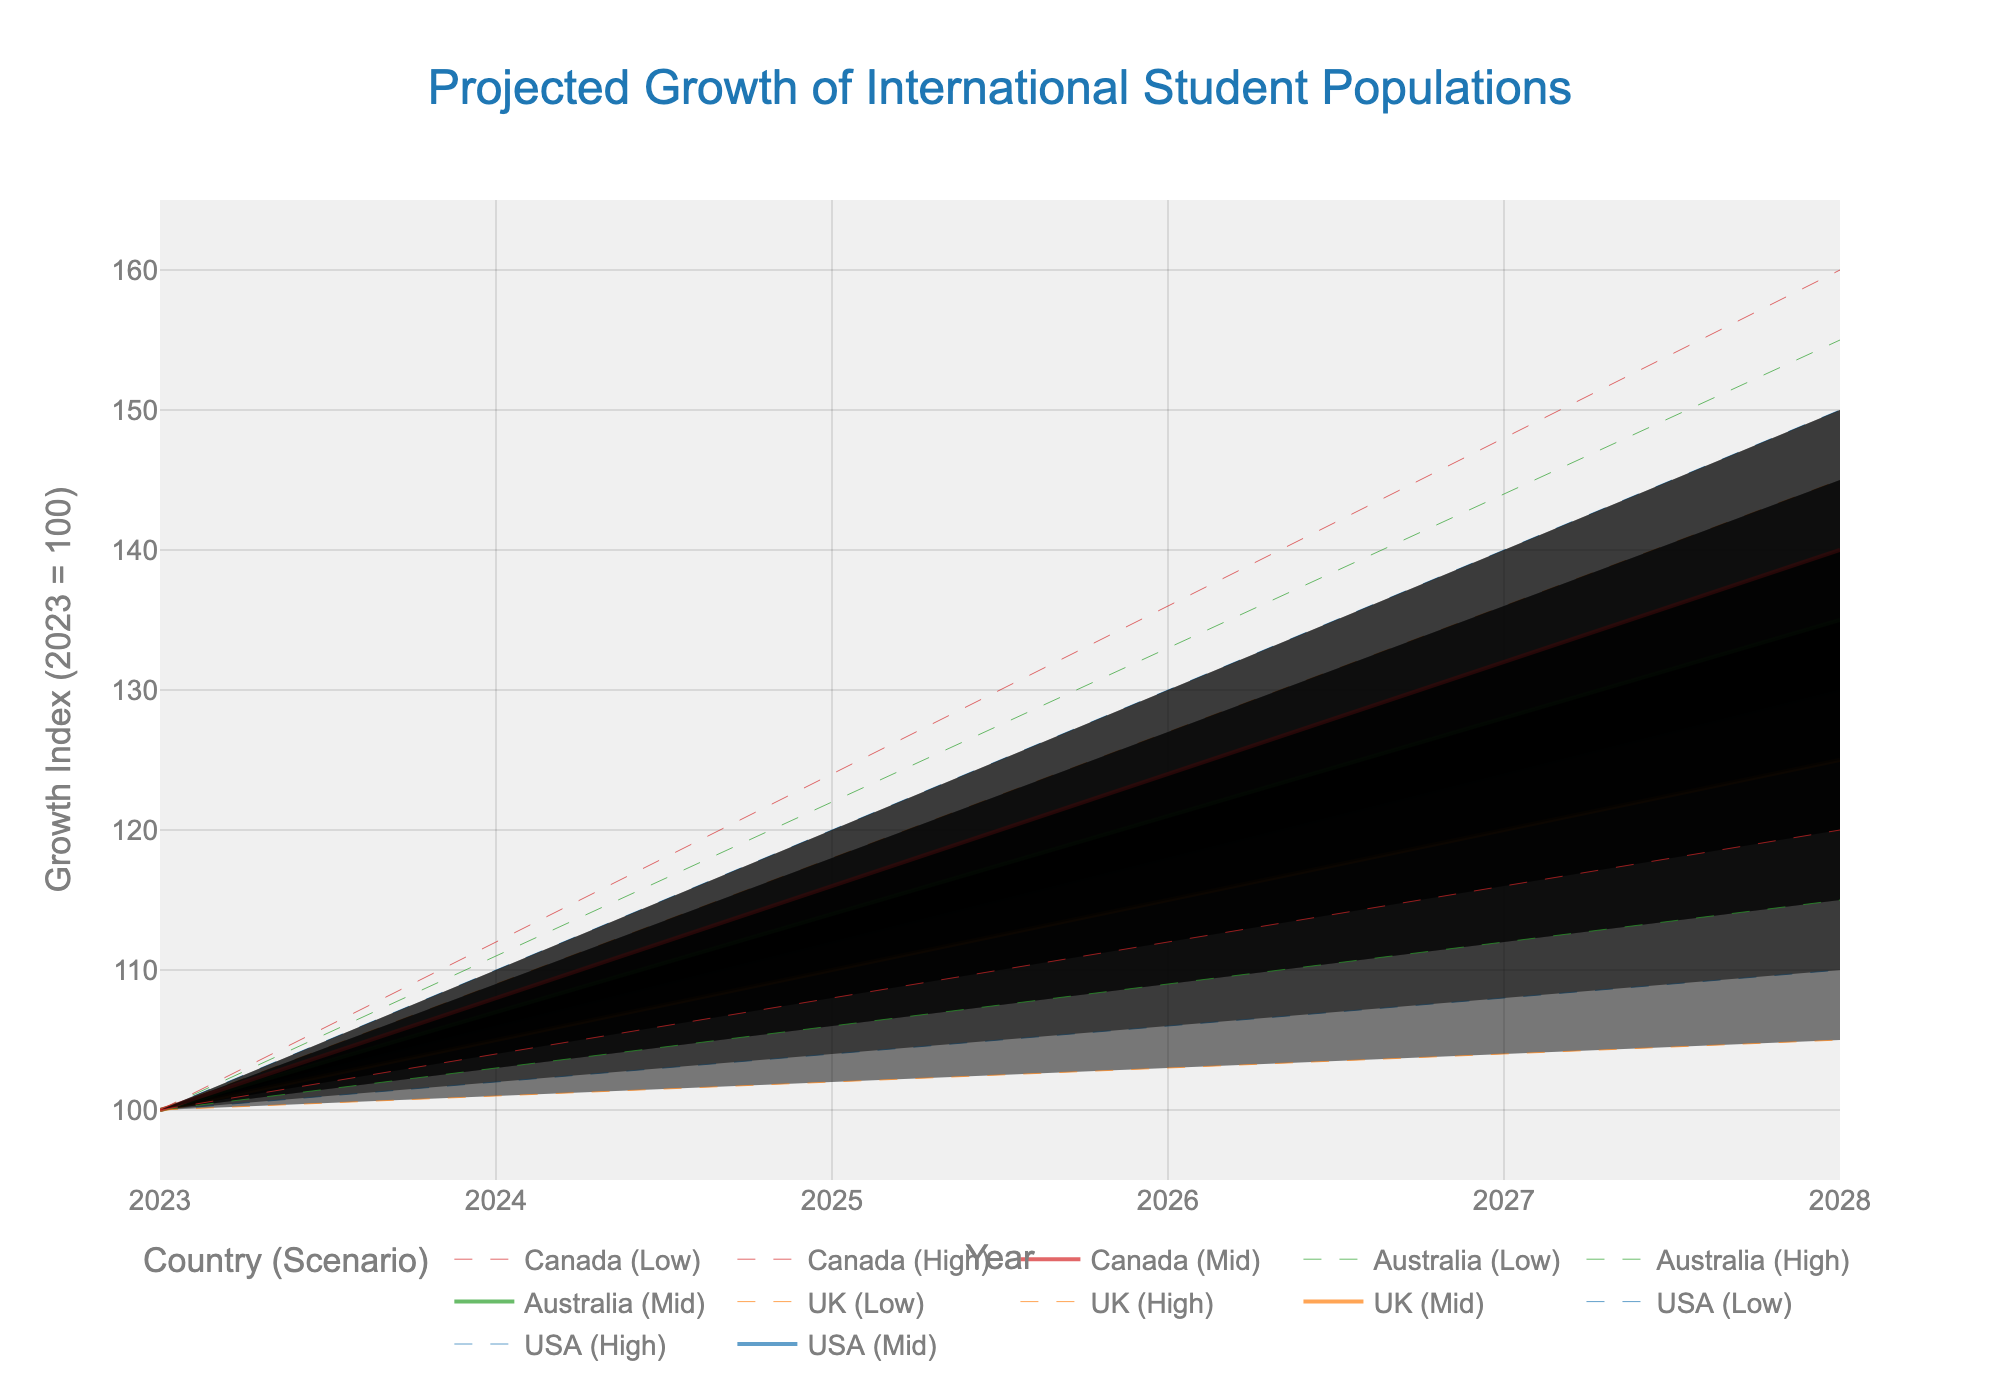What's the title of the figure? The figure's title is displayed at the top-center of the chart and reads 'Projected Growth of International Student Populations'.
Answer: Projected Growth of International Student Populations Which country has the highest projected growth in 2028 under the 'High' scenario? The highest 'High' scenario value for 2028 can be found by comparing the 'High' values for each country. Canada has the highest value of 160.
Answer: Canada What's the range of the growth index for Australia in 2024? In 2024, Australia's lowest and highest projected growth values are represented by the 'Low' and 'High' scenarios, which are 103 and 111, respectively. To find the range, subtract the lowest value from the highest value: 111 - 103 = 8.
Answer: 8 Which country's mid-scenario (Mid) projection surpasses 120 first? To find the first year when each country's 'Mid' value surpasses 120, look at data points year by year. Australia's 'Mid' value reaches 121 in 2026, which is earlier than the other countries.
Answer: Australia In which year does the UK have a 'Mid' scenario projected growth equivalent to the USA's 'Low-Mid' scenario? By examining the chart, you can compare the UK's 'Mid' values with the USA's 'Low-Mid' values. The UK's 'Mid' value of 110 in 2025 matches the USA's 'Low-Mid' value in the same year.
Answer: 2025 Compare the 'Low-Mid' scenario for Canada and Australia in 2027. Which is higher? Canada's 'Low-Mid' value for 2027 is 124, whereas Australia's 'Low-Mid' value for the same year is 120. Therefore, Canada's value is higher.
Answer: Canada Between 2023 and 2028, which country shows the highest increase in growth index under the 'Mid' scenario? Calculate the difference between the 'Mid' values for 2023 and 2028 for each country. Canada shows the highest increase from 100 to 140, which is an increase of 40.
Answer: Canada In 2025, which country has the narrowest range between ‘Low’ and ‘High’ scenarios? The range is calculated by the difference between 'Low' and 'High' values for each country in 2025. The ranges are USA: 120-104=16, UK: 118-102=16, Australia: 122-106=16, Canada: 124-108=16, which are all equal, so the narrowest range is shared by all countries.
Answer: USA, UK, Australia, Canada What's the average projected growth index for the USA in 2027 across all scenarios? To get the average, sum all projected values for 2027 for the USA and divide by the number of values: (108 + 116 + 124 + 132 + 140) / 5 = 124.
Answer: 124 How does the 'High-Mid' scenario for the UK in 2026 compare to the 'Mid' scenario for Australia in 2025? The UK’s 'High-Mid' for 2026 is 121, while Australia’s 'Mid' for 2025 is 114. The UK's value is higher by 121 - 114 = 7.
Answer: UK’s value is higher by 7 